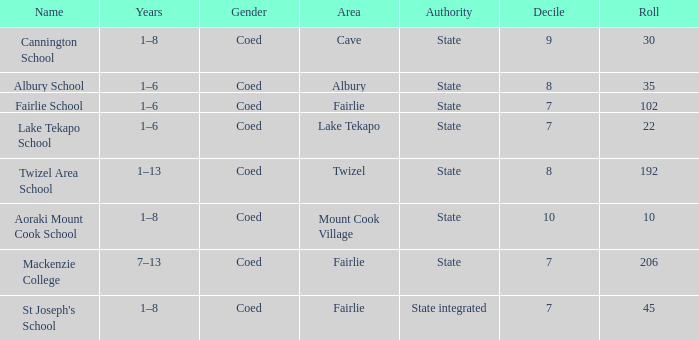What is the total Decile that has a state authority, fairlie area and roll smarter than 206? 1.0. 